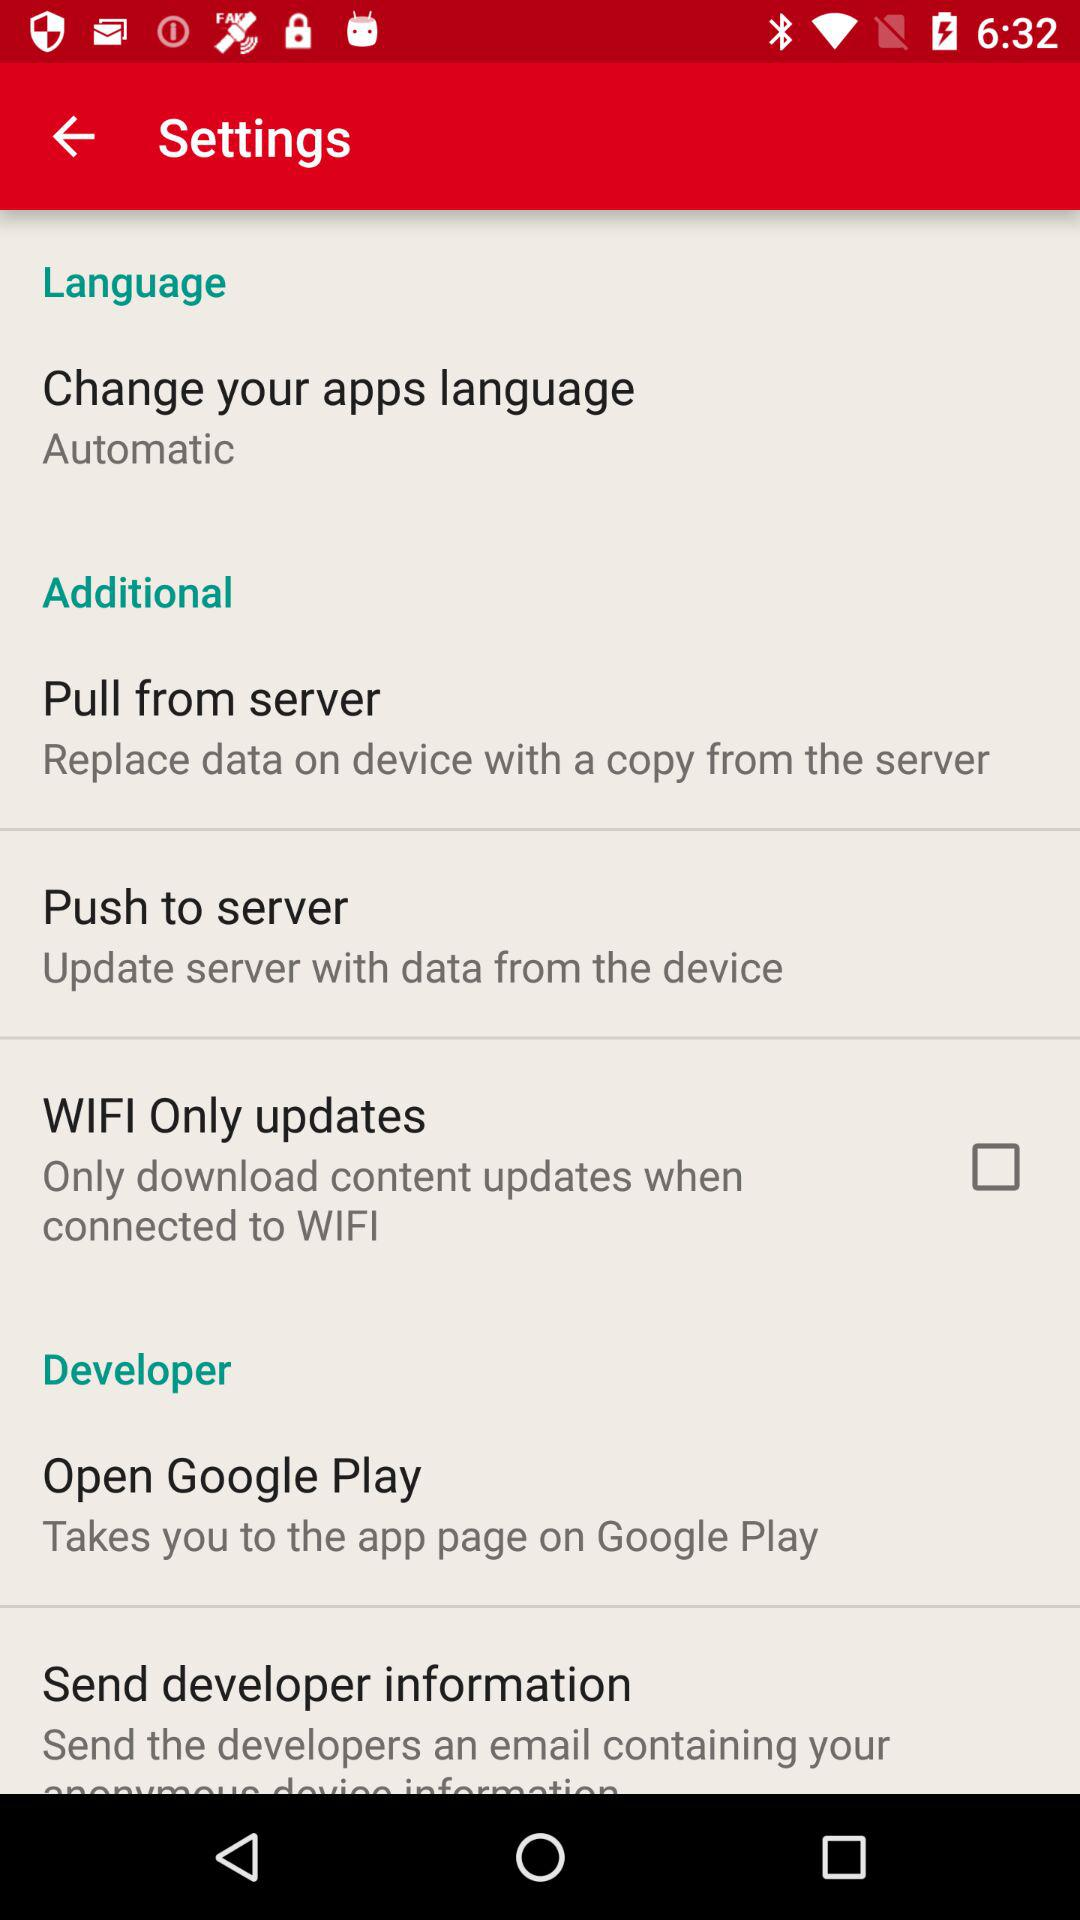When was the server updated?
When the provided information is insufficient, respond with <no answer>. <no answer> 